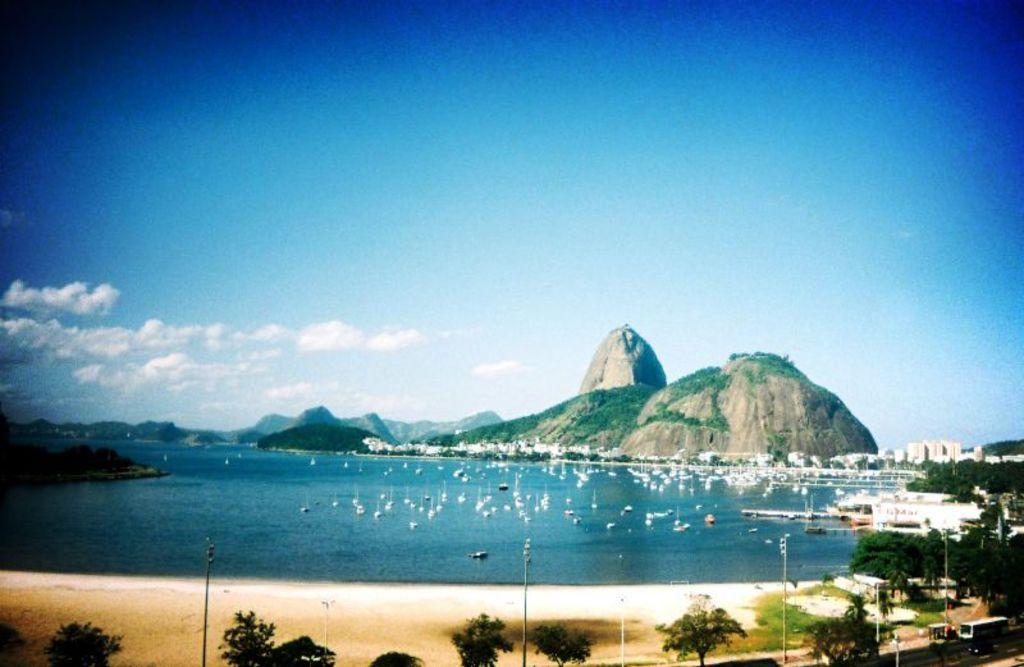Describe this image in one or two sentences. In the image we can see there are lot of tree and there are is water. There are boats standing in the water and there are buildings. Behind there are rock hills and there is a cloudy sky. 